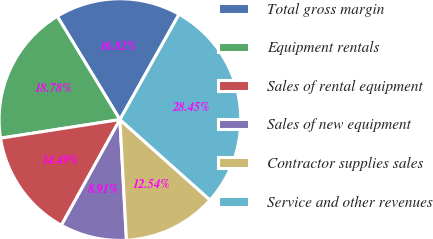<chart> <loc_0><loc_0><loc_500><loc_500><pie_chart><fcel>Total gross margin<fcel>Equipment rentals<fcel>Sales of rental equipment<fcel>Sales of new equipment<fcel>Contractor supplies sales<fcel>Service and other revenues<nl><fcel>16.82%<fcel>18.78%<fcel>14.49%<fcel>8.91%<fcel>12.54%<fcel>28.45%<nl></chart> 